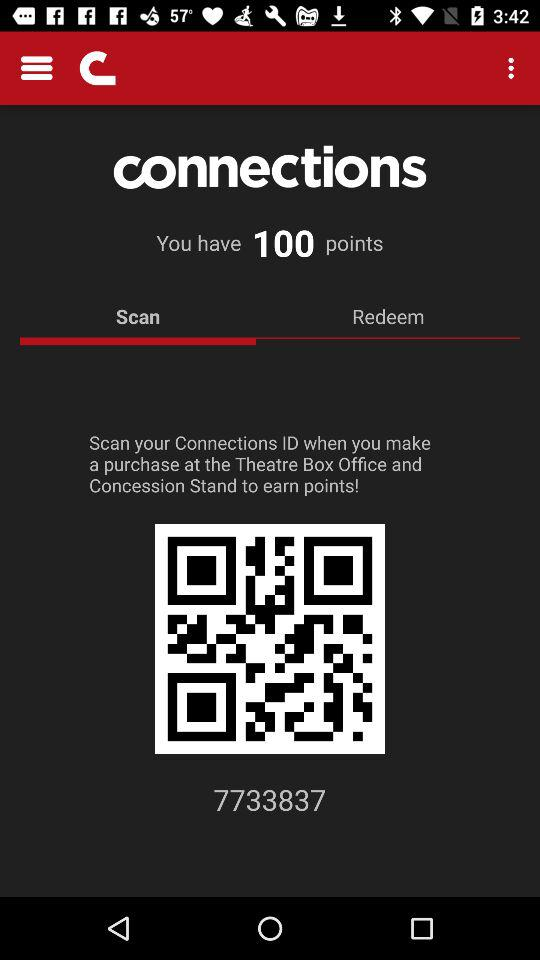What's the selected tab? The selected tab is "Scan". 